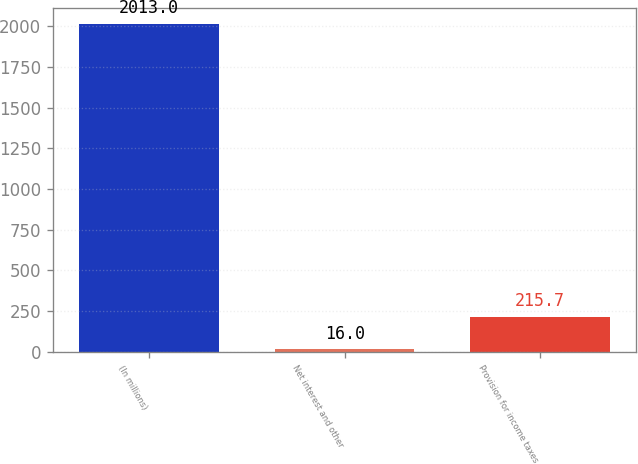Convert chart to OTSL. <chart><loc_0><loc_0><loc_500><loc_500><bar_chart><fcel>(In millions)<fcel>Net interest and other<fcel>Provision for income taxes<nl><fcel>2013<fcel>16<fcel>215.7<nl></chart> 